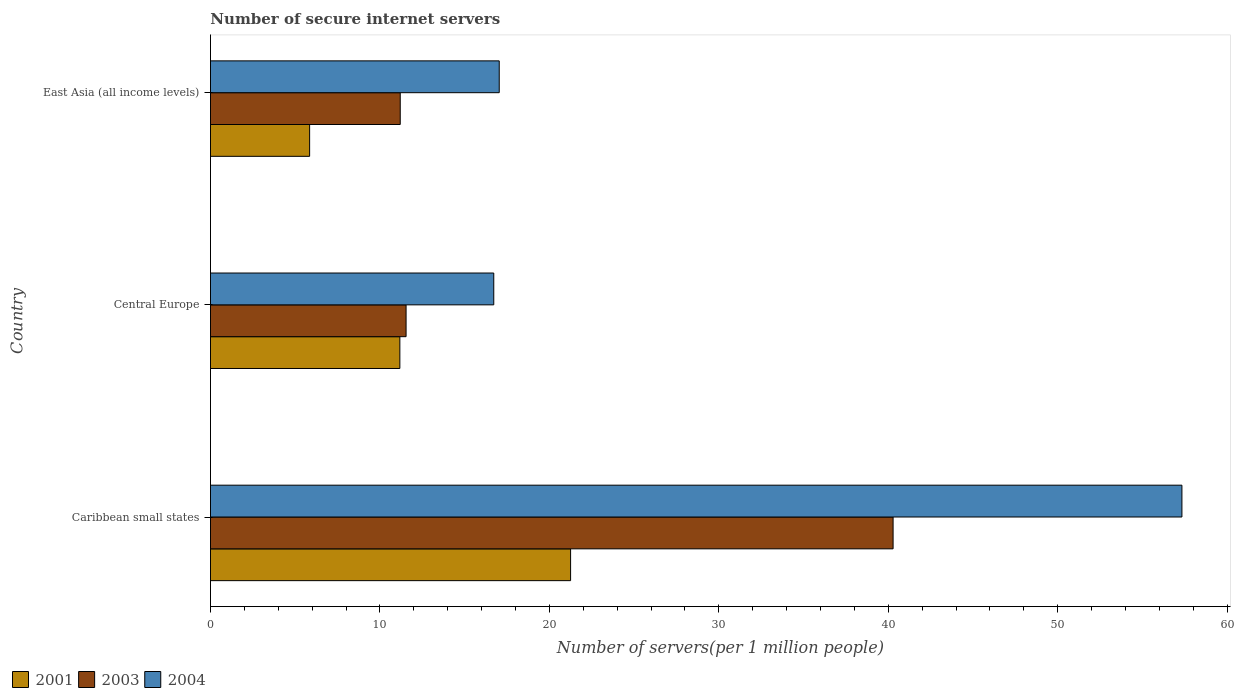Are the number of bars per tick equal to the number of legend labels?
Your answer should be compact. Yes. Are the number of bars on each tick of the Y-axis equal?
Keep it short and to the point. Yes. What is the label of the 1st group of bars from the top?
Provide a short and direct response. East Asia (all income levels). What is the number of secure internet servers in 2001 in Central Europe?
Offer a terse response. 11.18. Across all countries, what is the maximum number of secure internet servers in 2001?
Offer a terse response. 21.25. Across all countries, what is the minimum number of secure internet servers in 2003?
Your response must be concise. 11.2. In which country was the number of secure internet servers in 2003 maximum?
Ensure brevity in your answer.  Caribbean small states. In which country was the number of secure internet servers in 2001 minimum?
Offer a terse response. East Asia (all income levels). What is the total number of secure internet servers in 2004 in the graph?
Your answer should be compact. 91.09. What is the difference between the number of secure internet servers in 2003 in Central Europe and that in East Asia (all income levels)?
Your answer should be very brief. 0.35. What is the difference between the number of secure internet servers in 2003 in Caribbean small states and the number of secure internet servers in 2004 in East Asia (all income levels)?
Offer a terse response. 23.24. What is the average number of secure internet servers in 2004 per country?
Keep it short and to the point. 30.36. What is the difference between the number of secure internet servers in 2003 and number of secure internet servers in 2004 in Central Europe?
Ensure brevity in your answer.  -5.17. What is the ratio of the number of secure internet servers in 2001 in Caribbean small states to that in East Asia (all income levels)?
Give a very brief answer. 3.63. Is the number of secure internet servers in 2004 in Caribbean small states less than that in Central Europe?
Offer a terse response. No. What is the difference between the highest and the second highest number of secure internet servers in 2004?
Your answer should be very brief. 40.29. What is the difference between the highest and the lowest number of secure internet servers in 2004?
Your answer should be compact. 40.61. In how many countries, is the number of secure internet servers in 2003 greater than the average number of secure internet servers in 2003 taken over all countries?
Ensure brevity in your answer.  1. What does the 1st bar from the top in Caribbean small states represents?
Offer a very short reply. 2004. Is it the case that in every country, the sum of the number of secure internet servers in 2004 and number of secure internet servers in 2001 is greater than the number of secure internet servers in 2003?
Offer a terse response. Yes. How many countries are there in the graph?
Offer a very short reply. 3. What is the difference between two consecutive major ticks on the X-axis?
Ensure brevity in your answer.  10. Does the graph contain grids?
Your answer should be very brief. No. How many legend labels are there?
Your answer should be compact. 3. How are the legend labels stacked?
Your answer should be compact. Horizontal. What is the title of the graph?
Your answer should be very brief. Number of secure internet servers. What is the label or title of the X-axis?
Your answer should be compact. Number of servers(per 1 million people). What is the label or title of the Y-axis?
Offer a terse response. Country. What is the Number of servers(per 1 million people) of 2001 in Caribbean small states?
Provide a succinct answer. 21.25. What is the Number of servers(per 1 million people) of 2003 in Caribbean small states?
Your answer should be very brief. 40.28. What is the Number of servers(per 1 million people) in 2004 in Caribbean small states?
Give a very brief answer. 57.33. What is the Number of servers(per 1 million people) of 2001 in Central Europe?
Give a very brief answer. 11.18. What is the Number of servers(per 1 million people) in 2003 in Central Europe?
Provide a short and direct response. 11.54. What is the Number of servers(per 1 million people) of 2004 in Central Europe?
Ensure brevity in your answer.  16.72. What is the Number of servers(per 1 million people) of 2001 in East Asia (all income levels)?
Your answer should be very brief. 5.85. What is the Number of servers(per 1 million people) in 2003 in East Asia (all income levels)?
Ensure brevity in your answer.  11.2. What is the Number of servers(per 1 million people) of 2004 in East Asia (all income levels)?
Make the answer very short. 17.04. Across all countries, what is the maximum Number of servers(per 1 million people) in 2001?
Ensure brevity in your answer.  21.25. Across all countries, what is the maximum Number of servers(per 1 million people) of 2003?
Keep it short and to the point. 40.28. Across all countries, what is the maximum Number of servers(per 1 million people) of 2004?
Ensure brevity in your answer.  57.33. Across all countries, what is the minimum Number of servers(per 1 million people) in 2001?
Your response must be concise. 5.85. Across all countries, what is the minimum Number of servers(per 1 million people) in 2003?
Your answer should be very brief. 11.2. Across all countries, what is the minimum Number of servers(per 1 million people) of 2004?
Offer a very short reply. 16.72. What is the total Number of servers(per 1 million people) in 2001 in the graph?
Your response must be concise. 38.28. What is the total Number of servers(per 1 million people) in 2003 in the graph?
Give a very brief answer. 63.03. What is the total Number of servers(per 1 million people) in 2004 in the graph?
Your response must be concise. 91.09. What is the difference between the Number of servers(per 1 million people) in 2001 in Caribbean small states and that in Central Europe?
Provide a succinct answer. 10.08. What is the difference between the Number of servers(per 1 million people) in 2003 in Caribbean small states and that in Central Europe?
Offer a very short reply. 28.74. What is the difference between the Number of servers(per 1 million people) of 2004 in Caribbean small states and that in Central Europe?
Offer a terse response. 40.61. What is the difference between the Number of servers(per 1 million people) of 2001 in Caribbean small states and that in East Asia (all income levels)?
Offer a very short reply. 15.4. What is the difference between the Number of servers(per 1 million people) in 2003 in Caribbean small states and that in East Asia (all income levels)?
Your answer should be very brief. 29.09. What is the difference between the Number of servers(per 1 million people) in 2004 in Caribbean small states and that in East Asia (all income levels)?
Offer a very short reply. 40.29. What is the difference between the Number of servers(per 1 million people) of 2001 in Central Europe and that in East Asia (all income levels)?
Offer a very short reply. 5.33. What is the difference between the Number of servers(per 1 million people) in 2003 in Central Europe and that in East Asia (all income levels)?
Keep it short and to the point. 0.35. What is the difference between the Number of servers(per 1 million people) in 2004 in Central Europe and that in East Asia (all income levels)?
Give a very brief answer. -0.32. What is the difference between the Number of servers(per 1 million people) of 2001 in Caribbean small states and the Number of servers(per 1 million people) of 2003 in Central Europe?
Make the answer very short. 9.71. What is the difference between the Number of servers(per 1 million people) in 2001 in Caribbean small states and the Number of servers(per 1 million people) in 2004 in Central Europe?
Offer a very short reply. 4.53. What is the difference between the Number of servers(per 1 million people) in 2003 in Caribbean small states and the Number of servers(per 1 million people) in 2004 in Central Europe?
Provide a succinct answer. 23.57. What is the difference between the Number of servers(per 1 million people) of 2001 in Caribbean small states and the Number of servers(per 1 million people) of 2003 in East Asia (all income levels)?
Your response must be concise. 10.05. What is the difference between the Number of servers(per 1 million people) of 2001 in Caribbean small states and the Number of servers(per 1 million people) of 2004 in East Asia (all income levels)?
Ensure brevity in your answer.  4.21. What is the difference between the Number of servers(per 1 million people) in 2003 in Caribbean small states and the Number of servers(per 1 million people) in 2004 in East Asia (all income levels)?
Your response must be concise. 23.24. What is the difference between the Number of servers(per 1 million people) in 2001 in Central Europe and the Number of servers(per 1 million people) in 2003 in East Asia (all income levels)?
Your answer should be very brief. -0.02. What is the difference between the Number of servers(per 1 million people) of 2001 in Central Europe and the Number of servers(per 1 million people) of 2004 in East Asia (all income levels)?
Your answer should be compact. -5.86. What is the difference between the Number of servers(per 1 million people) in 2003 in Central Europe and the Number of servers(per 1 million people) in 2004 in East Asia (all income levels)?
Your answer should be very brief. -5.5. What is the average Number of servers(per 1 million people) of 2001 per country?
Your answer should be compact. 12.76. What is the average Number of servers(per 1 million people) of 2003 per country?
Your answer should be compact. 21.01. What is the average Number of servers(per 1 million people) in 2004 per country?
Make the answer very short. 30.36. What is the difference between the Number of servers(per 1 million people) of 2001 and Number of servers(per 1 million people) of 2003 in Caribbean small states?
Offer a very short reply. -19.03. What is the difference between the Number of servers(per 1 million people) of 2001 and Number of servers(per 1 million people) of 2004 in Caribbean small states?
Ensure brevity in your answer.  -36.08. What is the difference between the Number of servers(per 1 million people) of 2003 and Number of servers(per 1 million people) of 2004 in Caribbean small states?
Make the answer very short. -17.04. What is the difference between the Number of servers(per 1 million people) of 2001 and Number of servers(per 1 million people) of 2003 in Central Europe?
Make the answer very short. -0.37. What is the difference between the Number of servers(per 1 million people) in 2001 and Number of servers(per 1 million people) in 2004 in Central Europe?
Give a very brief answer. -5.54. What is the difference between the Number of servers(per 1 million people) of 2003 and Number of servers(per 1 million people) of 2004 in Central Europe?
Provide a succinct answer. -5.17. What is the difference between the Number of servers(per 1 million people) of 2001 and Number of servers(per 1 million people) of 2003 in East Asia (all income levels)?
Your answer should be compact. -5.35. What is the difference between the Number of servers(per 1 million people) in 2001 and Number of servers(per 1 million people) in 2004 in East Asia (all income levels)?
Your response must be concise. -11.19. What is the difference between the Number of servers(per 1 million people) in 2003 and Number of servers(per 1 million people) in 2004 in East Asia (all income levels)?
Make the answer very short. -5.84. What is the ratio of the Number of servers(per 1 million people) of 2001 in Caribbean small states to that in Central Europe?
Your answer should be compact. 1.9. What is the ratio of the Number of servers(per 1 million people) in 2003 in Caribbean small states to that in Central Europe?
Make the answer very short. 3.49. What is the ratio of the Number of servers(per 1 million people) in 2004 in Caribbean small states to that in Central Europe?
Ensure brevity in your answer.  3.43. What is the ratio of the Number of servers(per 1 million people) in 2001 in Caribbean small states to that in East Asia (all income levels)?
Provide a short and direct response. 3.63. What is the ratio of the Number of servers(per 1 million people) in 2003 in Caribbean small states to that in East Asia (all income levels)?
Your response must be concise. 3.6. What is the ratio of the Number of servers(per 1 million people) of 2004 in Caribbean small states to that in East Asia (all income levels)?
Ensure brevity in your answer.  3.36. What is the ratio of the Number of servers(per 1 million people) of 2001 in Central Europe to that in East Asia (all income levels)?
Offer a terse response. 1.91. What is the ratio of the Number of servers(per 1 million people) in 2003 in Central Europe to that in East Asia (all income levels)?
Your answer should be very brief. 1.03. What is the ratio of the Number of servers(per 1 million people) in 2004 in Central Europe to that in East Asia (all income levels)?
Make the answer very short. 0.98. What is the difference between the highest and the second highest Number of servers(per 1 million people) of 2001?
Your response must be concise. 10.08. What is the difference between the highest and the second highest Number of servers(per 1 million people) of 2003?
Ensure brevity in your answer.  28.74. What is the difference between the highest and the second highest Number of servers(per 1 million people) of 2004?
Keep it short and to the point. 40.29. What is the difference between the highest and the lowest Number of servers(per 1 million people) of 2001?
Ensure brevity in your answer.  15.4. What is the difference between the highest and the lowest Number of servers(per 1 million people) of 2003?
Ensure brevity in your answer.  29.09. What is the difference between the highest and the lowest Number of servers(per 1 million people) of 2004?
Make the answer very short. 40.61. 